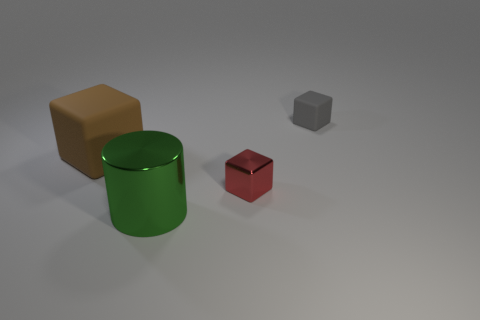How big is the metal cube in front of the matte cube that is left of the large shiny thing?
Give a very brief answer. Small. What number of things are green spheres or big objects?
Make the answer very short. 2. Are there any large metal things that have the same color as the large rubber block?
Make the answer very short. No. Are there fewer large rubber blocks than blocks?
Make the answer very short. Yes. What number of objects are cyan matte blocks or blocks on the left side of the gray thing?
Ensure brevity in your answer.  2. Are there any large red objects made of the same material as the big brown cube?
Give a very brief answer. No. There is a red cube that is the same size as the gray rubber object; what is its material?
Provide a short and direct response. Metal. What material is the cube on the right side of the shiny object that is on the right side of the big green metallic object made of?
Provide a succinct answer. Rubber. Do the large object behind the large green object and the red thing have the same shape?
Offer a terse response. Yes. There is another cube that is made of the same material as the brown cube; what color is it?
Provide a short and direct response. Gray. 